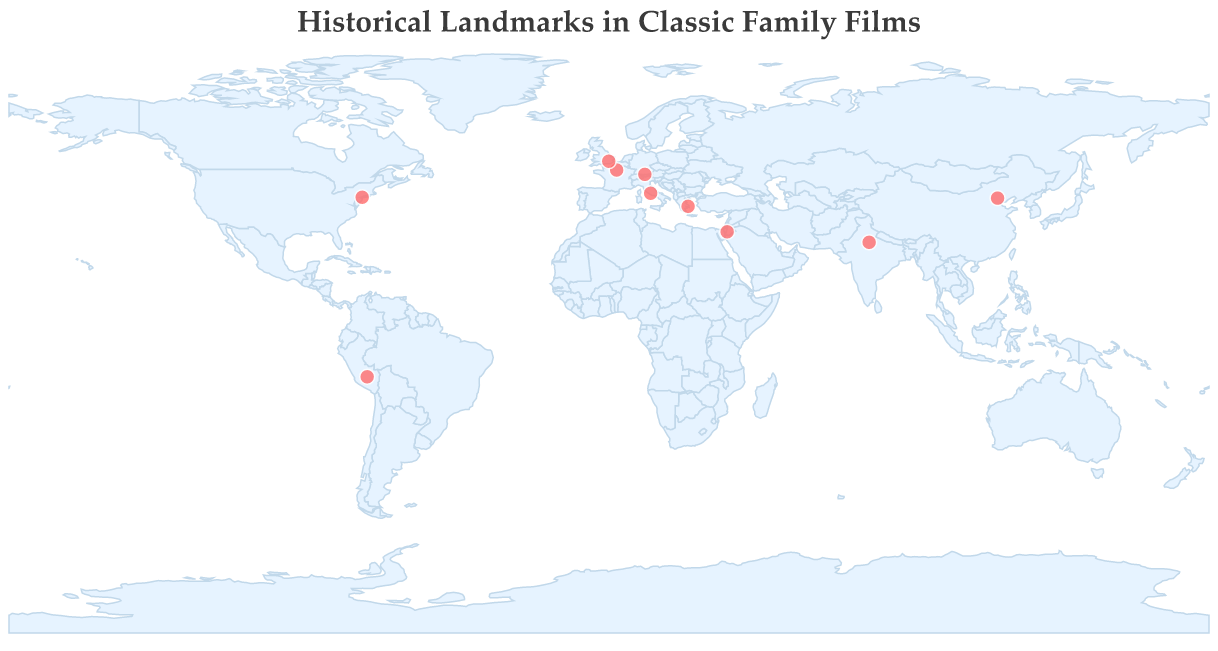What is the title of the figure? The title is usually placed at the top of the figure and is generally the first text that will catch attention.
Answer: Historical Landmarks in Classic Family Films How many landmarks are displayed in the figure? By counting the number of distinct data points marked on the map, we can determine the number of landmarks.
Answer: 10 Which landmark is located at the highest latitude? By identifying the data point with the maximum latitude value, we can find the landmark situated at the highest latitude.
Answer: Tower Bridge What film featured the landmark located at the highest latitude? After identifying the landmark with the highest latitude (Tower Bridge), we can look at the associated film in the data.
Answer: Mary Poppins Returns Which landmark is furthest west? The landmark with the smallest (most negative) longitude value represents the furthest west location.
Answer: Statue of Liberty What film featured the landmark furthest west? After identifying the furthest west landmark (Statue of Liberty), we can refer to the associated film in the dataset.
Answer: Annie How many landmarks are located in Europe? By examining the landmarks' locations and identifying which ones fall within Europe's geographical boundaries, we can count these landmarks.
Answer: 5 Which landmark is North or South of the Equator? By comparing the latitude value against 0, we can determine if the landmark positions are in the Northern or Southern Hemisphere. The landmark with a negative latitude value is south.
Answer: Machu Picchu Which historical landmark, featured in a film from the 1980s, is directly related to its latitude and longitude? Using both the year and latitude/longitude, cross-reference the film's release year within the 1980s and then identify the corresponding latitude and longitude to find the landmark.
Answer: Indiana Jones and the Last Crusade features Petra How many landmarks are associated with films released after the year 2000? By comparing the years of film releases to 2000, we can count how many landmarks are related to films released after 2000.
Answer: 3 